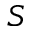Convert formula to latex. <formula><loc_0><loc_0><loc_500><loc_500>S</formula> 